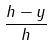Convert formula to latex. <formula><loc_0><loc_0><loc_500><loc_500>\frac { h - y } { h }</formula> 